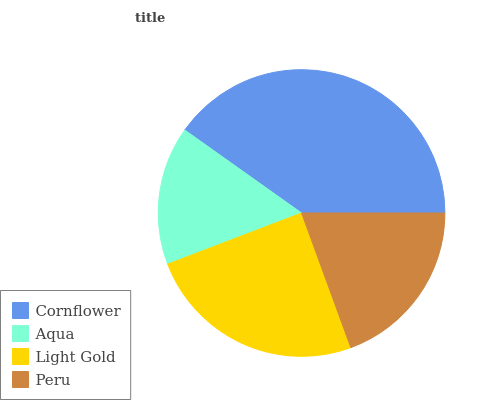Is Aqua the minimum?
Answer yes or no. Yes. Is Cornflower the maximum?
Answer yes or no. Yes. Is Light Gold the minimum?
Answer yes or no. No. Is Light Gold the maximum?
Answer yes or no. No. Is Light Gold greater than Aqua?
Answer yes or no. Yes. Is Aqua less than Light Gold?
Answer yes or no. Yes. Is Aqua greater than Light Gold?
Answer yes or no. No. Is Light Gold less than Aqua?
Answer yes or no. No. Is Light Gold the high median?
Answer yes or no. Yes. Is Peru the low median?
Answer yes or no. Yes. Is Cornflower the high median?
Answer yes or no. No. Is Cornflower the low median?
Answer yes or no. No. 